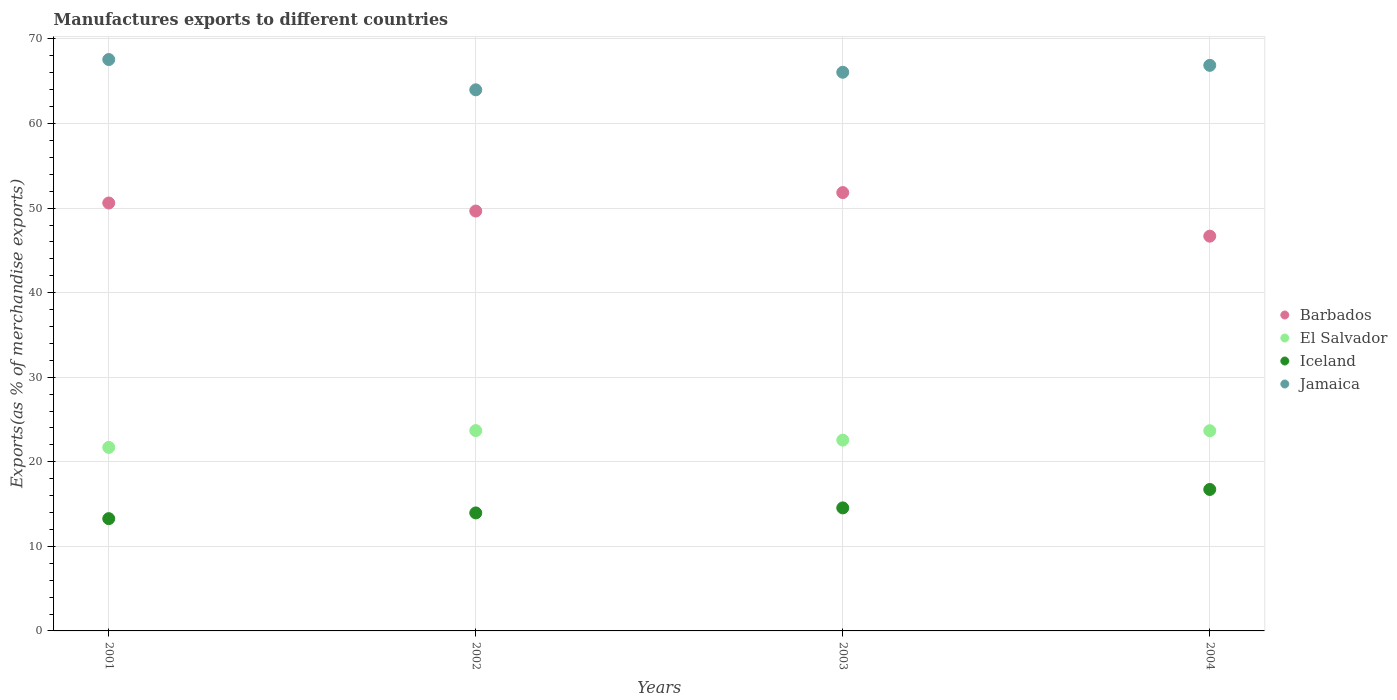Is the number of dotlines equal to the number of legend labels?
Your answer should be compact. Yes. What is the percentage of exports to different countries in El Salvador in 2003?
Provide a short and direct response. 22.56. Across all years, what is the maximum percentage of exports to different countries in Jamaica?
Offer a terse response. 67.57. Across all years, what is the minimum percentage of exports to different countries in Barbados?
Your response must be concise. 46.68. What is the total percentage of exports to different countries in Jamaica in the graph?
Give a very brief answer. 264.51. What is the difference between the percentage of exports to different countries in Jamaica in 2003 and that in 2004?
Your response must be concise. -0.82. What is the difference between the percentage of exports to different countries in Iceland in 2004 and the percentage of exports to different countries in Jamaica in 2003?
Your answer should be very brief. -49.34. What is the average percentage of exports to different countries in Iceland per year?
Provide a succinct answer. 14.63. In the year 2001, what is the difference between the percentage of exports to different countries in Barbados and percentage of exports to different countries in El Salvador?
Make the answer very short. 28.9. In how many years, is the percentage of exports to different countries in Barbados greater than 50 %?
Offer a very short reply. 2. What is the ratio of the percentage of exports to different countries in El Salvador in 2003 to that in 2004?
Your answer should be compact. 0.95. Is the percentage of exports to different countries in El Salvador in 2001 less than that in 2002?
Provide a succinct answer. Yes. What is the difference between the highest and the second highest percentage of exports to different countries in Barbados?
Make the answer very short. 1.23. What is the difference between the highest and the lowest percentage of exports to different countries in Jamaica?
Keep it short and to the point. 3.58. In how many years, is the percentage of exports to different countries in Jamaica greater than the average percentage of exports to different countries in Jamaica taken over all years?
Give a very brief answer. 2. Is the sum of the percentage of exports to different countries in Barbados in 2001 and 2004 greater than the maximum percentage of exports to different countries in Jamaica across all years?
Your answer should be compact. Yes. Is it the case that in every year, the sum of the percentage of exports to different countries in Barbados and percentage of exports to different countries in Iceland  is greater than the sum of percentage of exports to different countries in El Salvador and percentage of exports to different countries in Jamaica?
Provide a short and direct response. Yes. Is it the case that in every year, the sum of the percentage of exports to different countries in Iceland and percentage of exports to different countries in El Salvador  is greater than the percentage of exports to different countries in Jamaica?
Give a very brief answer. No. Does the percentage of exports to different countries in Iceland monotonically increase over the years?
Keep it short and to the point. Yes. Is the percentage of exports to different countries in Iceland strictly less than the percentage of exports to different countries in El Salvador over the years?
Give a very brief answer. Yes. How many dotlines are there?
Provide a succinct answer. 4. What is the difference between two consecutive major ticks on the Y-axis?
Keep it short and to the point. 10. Where does the legend appear in the graph?
Your response must be concise. Center right. How many legend labels are there?
Offer a very short reply. 4. How are the legend labels stacked?
Provide a short and direct response. Vertical. What is the title of the graph?
Provide a succinct answer. Manufactures exports to different countries. Does "Kyrgyz Republic" appear as one of the legend labels in the graph?
Provide a short and direct response. No. What is the label or title of the X-axis?
Provide a succinct answer. Years. What is the label or title of the Y-axis?
Your answer should be compact. Exports(as % of merchandise exports). What is the Exports(as % of merchandise exports) in Barbados in 2001?
Give a very brief answer. 50.61. What is the Exports(as % of merchandise exports) of El Salvador in 2001?
Give a very brief answer. 21.7. What is the Exports(as % of merchandise exports) of Iceland in 2001?
Your response must be concise. 13.28. What is the Exports(as % of merchandise exports) in Jamaica in 2001?
Ensure brevity in your answer.  67.57. What is the Exports(as % of merchandise exports) of Barbados in 2002?
Make the answer very short. 49.65. What is the Exports(as % of merchandise exports) in El Salvador in 2002?
Keep it short and to the point. 23.69. What is the Exports(as % of merchandise exports) of Iceland in 2002?
Provide a succinct answer. 13.95. What is the Exports(as % of merchandise exports) in Jamaica in 2002?
Provide a short and direct response. 63.99. What is the Exports(as % of merchandise exports) in Barbados in 2003?
Offer a terse response. 51.84. What is the Exports(as % of merchandise exports) of El Salvador in 2003?
Make the answer very short. 22.56. What is the Exports(as % of merchandise exports) of Iceland in 2003?
Your answer should be compact. 14.55. What is the Exports(as % of merchandise exports) of Jamaica in 2003?
Give a very brief answer. 66.07. What is the Exports(as % of merchandise exports) in Barbados in 2004?
Provide a short and direct response. 46.68. What is the Exports(as % of merchandise exports) in El Salvador in 2004?
Your answer should be compact. 23.67. What is the Exports(as % of merchandise exports) in Iceland in 2004?
Your answer should be very brief. 16.73. What is the Exports(as % of merchandise exports) of Jamaica in 2004?
Provide a succinct answer. 66.88. Across all years, what is the maximum Exports(as % of merchandise exports) in Barbados?
Keep it short and to the point. 51.84. Across all years, what is the maximum Exports(as % of merchandise exports) in El Salvador?
Make the answer very short. 23.69. Across all years, what is the maximum Exports(as % of merchandise exports) of Iceland?
Give a very brief answer. 16.73. Across all years, what is the maximum Exports(as % of merchandise exports) in Jamaica?
Your response must be concise. 67.57. Across all years, what is the minimum Exports(as % of merchandise exports) of Barbados?
Offer a very short reply. 46.68. Across all years, what is the minimum Exports(as % of merchandise exports) of El Salvador?
Keep it short and to the point. 21.7. Across all years, what is the minimum Exports(as % of merchandise exports) of Iceland?
Your response must be concise. 13.28. Across all years, what is the minimum Exports(as % of merchandise exports) of Jamaica?
Give a very brief answer. 63.99. What is the total Exports(as % of merchandise exports) of Barbados in the graph?
Give a very brief answer. 198.78. What is the total Exports(as % of merchandise exports) in El Salvador in the graph?
Keep it short and to the point. 91.63. What is the total Exports(as % of merchandise exports) in Iceland in the graph?
Offer a very short reply. 58.51. What is the total Exports(as % of merchandise exports) in Jamaica in the graph?
Provide a succinct answer. 264.51. What is the difference between the Exports(as % of merchandise exports) in Barbados in 2001 and that in 2002?
Your answer should be very brief. 0.95. What is the difference between the Exports(as % of merchandise exports) of El Salvador in 2001 and that in 2002?
Make the answer very short. -1.99. What is the difference between the Exports(as % of merchandise exports) in Iceland in 2001 and that in 2002?
Your response must be concise. -0.68. What is the difference between the Exports(as % of merchandise exports) of Jamaica in 2001 and that in 2002?
Offer a terse response. 3.58. What is the difference between the Exports(as % of merchandise exports) of Barbados in 2001 and that in 2003?
Keep it short and to the point. -1.23. What is the difference between the Exports(as % of merchandise exports) of El Salvador in 2001 and that in 2003?
Offer a terse response. -0.86. What is the difference between the Exports(as % of merchandise exports) in Iceland in 2001 and that in 2003?
Give a very brief answer. -1.27. What is the difference between the Exports(as % of merchandise exports) in Jamaica in 2001 and that in 2003?
Your response must be concise. 1.5. What is the difference between the Exports(as % of merchandise exports) of Barbados in 2001 and that in 2004?
Offer a very short reply. 3.92. What is the difference between the Exports(as % of merchandise exports) of El Salvador in 2001 and that in 2004?
Give a very brief answer. -1.97. What is the difference between the Exports(as % of merchandise exports) of Iceland in 2001 and that in 2004?
Make the answer very short. -3.45. What is the difference between the Exports(as % of merchandise exports) of Jamaica in 2001 and that in 2004?
Offer a terse response. 0.69. What is the difference between the Exports(as % of merchandise exports) of Barbados in 2002 and that in 2003?
Your response must be concise. -2.18. What is the difference between the Exports(as % of merchandise exports) in El Salvador in 2002 and that in 2003?
Give a very brief answer. 1.12. What is the difference between the Exports(as % of merchandise exports) of Iceland in 2002 and that in 2003?
Provide a short and direct response. -0.59. What is the difference between the Exports(as % of merchandise exports) of Jamaica in 2002 and that in 2003?
Your answer should be very brief. -2.08. What is the difference between the Exports(as % of merchandise exports) of Barbados in 2002 and that in 2004?
Your answer should be very brief. 2.97. What is the difference between the Exports(as % of merchandise exports) in El Salvador in 2002 and that in 2004?
Your answer should be compact. 0.02. What is the difference between the Exports(as % of merchandise exports) in Iceland in 2002 and that in 2004?
Keep it short and to the point. -2.77. What is the difference between the Exports(as % of merchandise exports) in Jamaica in 2002 and that in 2004?
Your response must be concise. -2.89. What is the difference between the Exports(as % of merchandise exports) in Barbados in 2003 and that in 2004?
Provide a short and direct response. 5.15. What is the difference between the Exports(as % of merchandise exports) in El Salvador in 2003 and that in 2004?
Your response must be concise. -1.11. What is the difference between the Exports(as % of merchandise exports) in Iceland in 2003 and that in 2004?
Offer a terse response. -2.18. What is the difference between the Exports(as % of merchandise exports) of Jamaica in 2003 and that in 2004?
Offer a terse response. -0.82. What is the difference between the Exports(as % of merchandise exports) in Barbados in 2001 and the Exports(as % of merchandise exports) in El Salvador in 2002?
Make the answer very short. 26.92. What is the difference between the Exports(as % of merchandise exports) of Barbados in 2001 and the Exports(as % of merchandise exports) of Iceland in 2002?
Provide a succinct answer. 36.65. What is the difference between the Exports(as % of merchandise exports) of Barbados in 2001 and the Exports(as % of merchandise exports) of Jamaica in 2002?
Offer a very short reply. -13.38. What is the difference between the Exports(as % of merchandise exports) of El Salvador in 2001 and the Exports(as % of merchandise exports) of Iceland in 2002?
Keep it short and to the point. 7.75. What is the difference between the Exports(as % of merchandise exports) of El Salvador in 2001 and the Exports(as % of merchandise exports) of Jamaica in 2002?
Keep it short and to the point. -42.29. What is the difference between the Exports(as % of merchandise exports) of Iceland in 2001 and the Exports(as % of merchandise exports) of Jamaica in 2002?
Provide a short and direct response. -50.71. What is the difference between the Exports(as % of merchandise exports) in Barbados in 2001 and the Exports(as % of merchandise exports) in El Salvador in 2003?
Your answer should be very brief. 28.04. What is the difference between the Exports(as % of merchandise exports) in Barbados in 2001 and the Exports(as % of merchandise exports) in Iceland in 2003?
Keep it short and to the point. 36.06. What is the difference between the Exports(as % of merchandise exports) of Barbados in 2001 and the Exports(as % of merchandise exports) of Jamaica in 2003?
Provide a short and direct response. -15.46. What is the difference between the Exports(as % of merchandise exports) in El Salvador in 2001 and the Exports(as % of merchandise exports) in Iceland in 2003?
Your answer should be compact. 7.15. What is the difference between the Exports(as % of merchandise exports) in El Salvador in 2001 and the Exports(as % of merchandise exports) in Jamaica in 2003?
Provide a succinct answer. -44.37. What is the difference between the Exports(as % of merchandise exports) in Iceland in 2001 and the Exports(as % of merchandise exports) in Jamaica in 2003?
Make the answer very short. -52.79. What is the difference between the Exports(as % of merchandise exports) of Barbados in 2001 and the Exports(as % of merchandise exports) of El Salvador in 2004?
Keep it short and to the point. 26.93. What is the difference between the Exports(as % of merchandise exports) of Barbados in 2001 and the Exports(as % of merchandise exports) of Iceland in 2004?
Your response must be concise. 33.88. What is the difference between the Exports(as % of merchandise exports) of Barbados in 2001 and the Exports(as % of merchandise exports) of Jamaica in 2004?
Keep it short and to the point. -16.28. What is the difference between the Exports(as % of merchandise exports) of El Salvador in 2001 and the Exports(as % of merchandise exports) of Iceland in 2004?
Provide a succinct answer. 4.97. What is the difference between the Exports(as % of merchandise exports) in El Salvador in 2001 and the Exports(as % of merchandise exports) in Jamaica in 2004?
Give a very brief answer. -45.18. What is the difference between the Exports(as % of merchandise exports) in Iceland in 2001 and the Exports(as % of merchandise exports) in Jamaica in 2004?
Your response must be concise. -53.61. What is the difference between the Exports(as % of merchandise exports) of Barbados in 2002 and the Exports(as % of merchandise exports) of El Salvador in 2003?
Provide a short and direct response. 27.09. What is the difference between the Exports(as % of merchandise exports) of Barbados in 2002 and the Exports(as % of merchandise exports) of Iceland in 2003?
Your response must be concise. 35.1. What is the difference between the Exports(as % of merchandise exports) in Barbados in 2002 and the Exports(as % of merchandise exports) in Jamaica in 2003?
Offer a terse response. -16.41. What is the difference between the Exports(as % of merchandise exports) in El Salvador in 2002 and the Exports(as % of merchandise exports) in Iceland in 2003?
Your response must be concise. 9.14. What is the difference between the Exports(as % of merchandise exports) of El Salvador in 2002 and the Exports(as % of merchandise exports) of Jamaica in 2003?
Offer a terse response. -42.38. What is the difference between the Exports(as % of merchandise exports) in Iceland in 2002 and the Exports(as % of merchandise exports) in Jamaica in 2003?
Offer a terse response. -52.11. What is the difference between the Exports(as % of merchandise exports) of Barbados in 2002 and the Exports(as % of merchandise exports) of El Salvador in 2004?
Offer a very short reply. 25.98. What is the difference between the Exports(as % of merchandise exports) of Barbados in 2002 and the Exports(as % of merchandise exports) of Iceland in 2004?
Your answer should be very brief. 32.92. What is the difference between the Exports(as % of merchandise exports) in Barbados in 2002 and the Exports(as % of merchandise exports) in Jamaica in 2004?
Offer a terse response. -17.23. What is the difference between the Exports(as % of merchandise exports) in El Salvador in 2002 and the Exports(as % of merchandise exports) in Iceland in 2004?
Your answer should be very brief. 6.96. What is the difference between the Exports(as % of merchandise exports) in El Salvador in 2002 and the Exports(as % of merchandise exports) in Jamaica in 2004?
Your response must be concise. -43.2. What is the difference between the Exports(as % of merchandise exports) in Iceland in 2002 and the Exports(as % of merchandise exports) in Jamaica in 2004?
Provide a short and direct response. -52.93. What is the difference between the Exports(as % of merchandise exports) in Barbados in 2003 and the Exports(as % of merchandise exports) in El Salvador in 2004?
Offer a terse response. 28.16. What is the difference between the Exports(as % of merchandise exports) in Barbados in 2003 and the Exports(as % of merchandise exports) in Iceland in 2004?
Keep it short and to the point. 35.11. What is the difference between the Exports(as % of merchandise exports) in Barbados in 2003 and the Exports(as % of merchandise exports) in Jamaica in 2004?
Your response must be concise. -15.05. What is the difference between the Exports(as % of merchandise exports) of El Salvador in 2003 and the Exports(as % of merchandise exports) of Iceland in 2004?
Your answer should be very brief. 5.84. What is the difference between the Exports(as % of merchandise exports) of El Salvador in 2003 and the Exports(as % of merchandise exports) of Jamaica in 2004?
Make the answer very short. -44.32. What is the difference between the Exports(as % of merchandise exports) in Iceland in 2003 and the Exports(as % of merchandise exports) in Jamaica in 2004?
Your response must be concise. -52.33. What is the average Exports(as % of merchandise exports) of Barbados per year?
Give a very brief answer. 49.69. What is the average Exports(as % of merchandise exports) in El Salvador per year?
Offer a terse response. 22.91. What is the average Exports(as % of merchandise exports) in Iceland per year?
Ensure brevity in your answer.  14.63. What is the average Exports(as % of merchandise exports) of Jamaica per year?
Provide a succinct answer. 66.13. In the year 2001, what is the difference between the Exports(as % of merchandise exports) in Barbados and Exports(as % of merchandise exports) in El Salvador?
Make the answer very short. 28.9. In the year 2001, what is the difference between the Exports(as % of merchandise exports) in Barbados and Exports(as % of merchandise exports) in Iceland?
Offer a terse response. 37.33. In the year 2001, what is the difference between the Exports(as % of merchandise exports) in Barbados and Exports(as % of merchandise exports) in Jamaica?
Provide a succinct answer. -16.97. In the year 2001, what is the difference between the Exports(as % of merchandise exports) of El Salvador and Exports(as % of merchandise exports) of Iceland?
Make the answer very short. 8.42. In the year 2001, what is the difference between the Exports(as % of merchandise exports) in El Salvador and Exports(as % of merchandise exports) in Jamaica?
Ensure brevity in your answer.  -45.87. In the year 2001, what is the difference between the Exports(as % of merchandise exports) of Iceland and Exports(as % of merchandise exports) of Jamaica?
Your response must be concise. -54.29. In the year 2002, what is the difference between the Exports(as % of merchandise exports) of Barbados and Exports(as % of merchandise exports) of El Salvador?
Your response must be concise. 25.97. In the year 2002, what is the difference between the Exports(as % of merchandise exports) of Barbados and Exports(as % of merchandise exports) of Iceland?
Keep it short and to the point. 35.7. In the year 2002, what is the difference between the Exports(as % of merchandise exports) in Barbados and Exports(as % of merchandise exports) in Jamaica?
Ensure brevity in your answer.  -14.34. In the year 2002, what is the difference between the Exports(as % of merchandise exports) of El Salvador and Exports(as % of merchandise exports) of Iceland?
Ensure brevity in your answer.  9.73. In the year 2002, what is the difference between the Exports(as % of merchandise exports) in El Salvador and Exports(as % of merchandise exports) in Jamaica?
Your answer should be very brief. -40.3. In the year 2002, what is the difference between the Exports(as % of merchandise exports) of Iceland and Exports(as % of merchandise exports) of Jamaica?
Provide a succinct answer. -50.03. In the year 2003, what is the difference between the Exports(as % of merchandise exports) in Barbados and Exports(as % of merchandise exports) in El Salvador?
Give a very brief answer. 29.27. In the year 2003, what is the difference between the Exports(as % of merchandise exports) in Barbados and Exports(as % of merchandise exports) in Iceland?
Offer a very short reply. 37.29. In the year 2003, what is the difference between the Exports(as % of merchandise exports) of Barbados and Exports(as % of merchandise exports) of Jamaica?
Your response must be concise. -14.23. In the year 2003, what is the difference between the Exports(as % of merchandise exports) of El Salvador and Exports(as % of merchandise exports) of Iceland?
Make the answer very short. 8.02. In the year 2003, what is the difference between the Exports(as % of merchandise exports) of El Salvador and Exports(as % of merchandise exports) of Jamaica?
Offer a very short reply. -43.5. In the year 2003, what is the difference between the Exports(as % of merchandise exports) of Iceland and Exports(as % of merchandise exports) of Jamaica?
Provide a succinct answer. -51.52. In the year 2004, what is the difference between the Exports(as % of merchandise exports) in Barbados and Exports(as % of merchandise exports) in El Salvador?
Offer a terse response. 23.01. In the year 2004, what is the difference between the Exports(as % of merchandise exports) in Barbados and Exports(as % of merchandise exports) in Iceland?
Provide a succinct answer. 29.95. In the year 2004, what is the difference between the Exports(as % of merchandise exports) in Barbados and Exports(as % of merchandise exports) in Jamaica?
Make the answer very short. -20.2. In the year 2004, what is the difference between the Exports(as % of merchandise exports) in El Salvador and Exports(as % of merchandise exports) in Iceland?
Ensure brevity in your answer.  6.94. In the year 2004, what is the difference between the Exports(as % of merchandise exports) in El Salvador and Exports(as % of merchandise exports) in Jamaica?
Offer a terse response. -43.21. In the year 2004, what is the difference between the Exports(as % of merchandise exports) in Iceland and Exports(as % of merchandise exports) in Jamaica?
Give a very brief answer. -50.15. What is the ratio of the Exports(as % of merchandise exports) in Barbados in 2001 to that in 2002?
Make the answer very short. 1.02. What is the ratio of the Exports(as % of merchandise exports) in El Salvador in 2001 to that in 2002?
Give a very brief answer. 0.92. What is the ratio of the Exports(as % of merchandise exports) of Iceland in 2001 to that in 2002?
Provide a succinct answer. 0.95. What is the ratio of the Exports(as % of merchandise exports) in Jamaica in 2001 to that in 2002?
Give a very brief answer. 1.06. What is the ratio of the Exports(as % of merchandise exports) of Barbados in 2001 to that in 2003?
Your answer should be very brief. 0.98. What is the ratio of the Exports(as % of merchandise exports) in El Salvador in 2001 to that in 2003?
Give a very brief answer. 0.96. What is the ratio of the Exports(as % of merchandise exports) of Iceland in 2001 to that in 2003?
Your response must be concise. 0.91. What is the ratio of the Exports(as % of merchandise exports) in Jamaica in 2001 to that in 2003?
Your response must be concise. 1.02. What is the ratio of the Exports(as % of merchandise exports) in Barbados in 2001 to that in 2004?
Offer a very short reply. 1.08. What is the ratio of the Exports(as % of merchandise exports) of Iceland in 2001 to that in 2004?
Your response must be concise. 0.79. What is the ratio of the Exports(as % of merchandise exports) in Jamaica in 2001 to that in 2004?
Give a very brief answer. 1.01. What is the ratio of the Exports(as % of merchandise exports) in Barbados in 2002 to that in 2003?
Ensure brevity in your answer.  0.96. What is the ratio of the Exports(as % of merchandise exports) of El Salvador in 2002 to that in 2003?
Offer a terse response. 1.05. What is the ratio of the Exports(as % of merchandise exports) in Iceland in 2002 to that in 2003?
Give a very brief answer. 0.96. What is the ratio of the Exports(as % of merchandise exports) in Jamaica in 2002 to that in 2003?
Your answer should be compact. 0.97. What is the ratio of the Exports(as % of merchandise exports) in Barbados in 2002 to that in 2004?
Give a very brief answer. 1.06. What is the ratio of the Exports(as % of merchandise exports) of Iceland in 2002 to that in 2004?
Make the answer very short. 0.83. What is the ratio of the Exports(as % of merchandise exports) of Jamaica in 2002 to that in 2004?
Make the answer very short. 0.96. What is the ratio of the Exports(as % of merchandise exports) in Barbados in 2003 to that in 2004?
Ensure brevity in your answer.  1.11. What is the ratio of the Exports(as % of merchandise exports) of El Salvador in 2003 to that in 2004?
Ensure brevity in your answer.  0.95. What is the ratio of the Exports(as % of merchandise exports) of Iceland in 2003 to that in 2004?
Offer a very short reply. 0.87. What is the difference between the highest and the second highest Exports(as % of merchandise exports) of Barbados?
Offer a terse response. 1.23. What is the difference between the highest and the second highest Exports(as % of merchandise exports) in El Salvador?
Make the answer very short. 0.02. What is the difference between the highest and the second highest Exports(as % of merchandise exports) in Iceland?
Give a very brief answer. 2.18. What is the difference between the highest and the second highest Exports(as % of merchandise exports) in Jamaica?
Provide a short and direct response. 0.69. What is the difference between the highest and the lowest Exports(as % of merchandise exports) of Barbados?
Keep it short and to the point. 5.15. What is the difference between the highest and the lowest Exports(as % of merchandise exports) of El Salvador?
Offer a very short reply. 1.99. What is the difference between the highest and the lowest Exports(as % of merchandise exports) of Iceland?
Provide a succinct answer. 3.45. What is the difference between the highest and the lowest Exports(as % of merchandise exports) of Jamaica?
Offer a terse response. 3.58. 